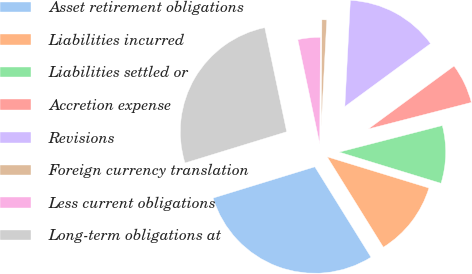<chart> <loc_0><loc_0><loc_500><loc_500><pie_chart><fcel>Asset retirement obligations<fcel>Liabilities incurred<fcel>Liabilities settled or<fcel>Accretion expense<fcel>Revisions<fcel>Foreign currency translation<fcel>Less current obligations<fcel>Long-term obligations at<nl><fcel>29.11%<fcel>11.42%<fcel>8.75%<fcel>6.07%<fcel>14.09%<fcel>0.73%<fcel>3.4%<fcel>26.44%<nl></chart> 